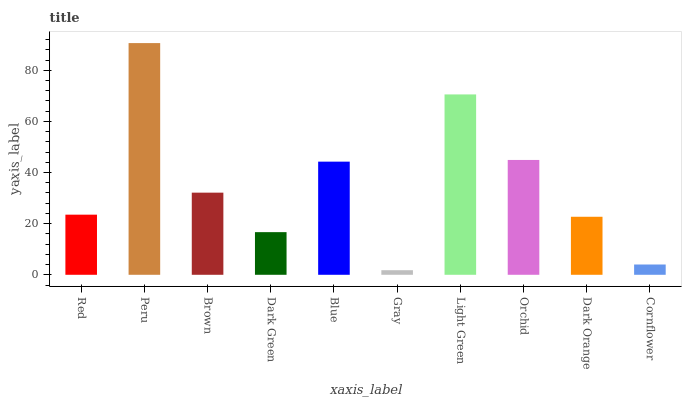Is Gray the minimum?
Answer yes or no. Yes. Is Peru the maximum?
Answer yes or no. Yes. Is Brown the minimum?
Answer yes or no. No. Is Brown the maximum?
Answer yes or no. No. Is Peru greater than Brown?
Answer yes or no. Yes. Is Brown less than Peru?
Answer yes or no. Yes. Is Brown greater than Peru?
Answer yes or no. No. Is Peru less than Brown?
Answer yes or no. No. Is Brown the high median?
Answer yes or no. Yes. Is Red the low median?
Answer yes or no. Yes. Is Cornflower the high median?
Answer yes or no. No. Is Orchid the low median?
Answer yes or no. No. 